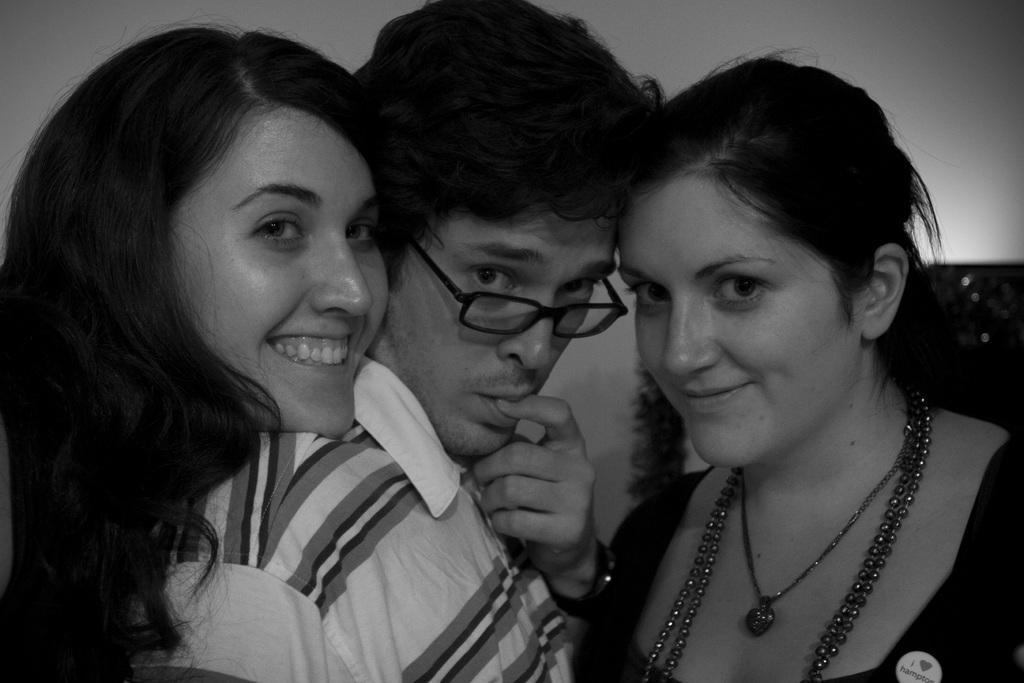In one or two sentences, can you explain what this image depicts? In the image in the center we can see three persons were standing. Except middle one,the rest of the two persons were smiling,which we can see on their faces. In the background there is a wall and few other objects. 